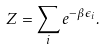Convert formula to latex. <formula><loc_0><loc_0><loc_500><loc_500>Z = \sum _ { i } e ^ { - \beta \epsilon _ { i } } .</formula> 